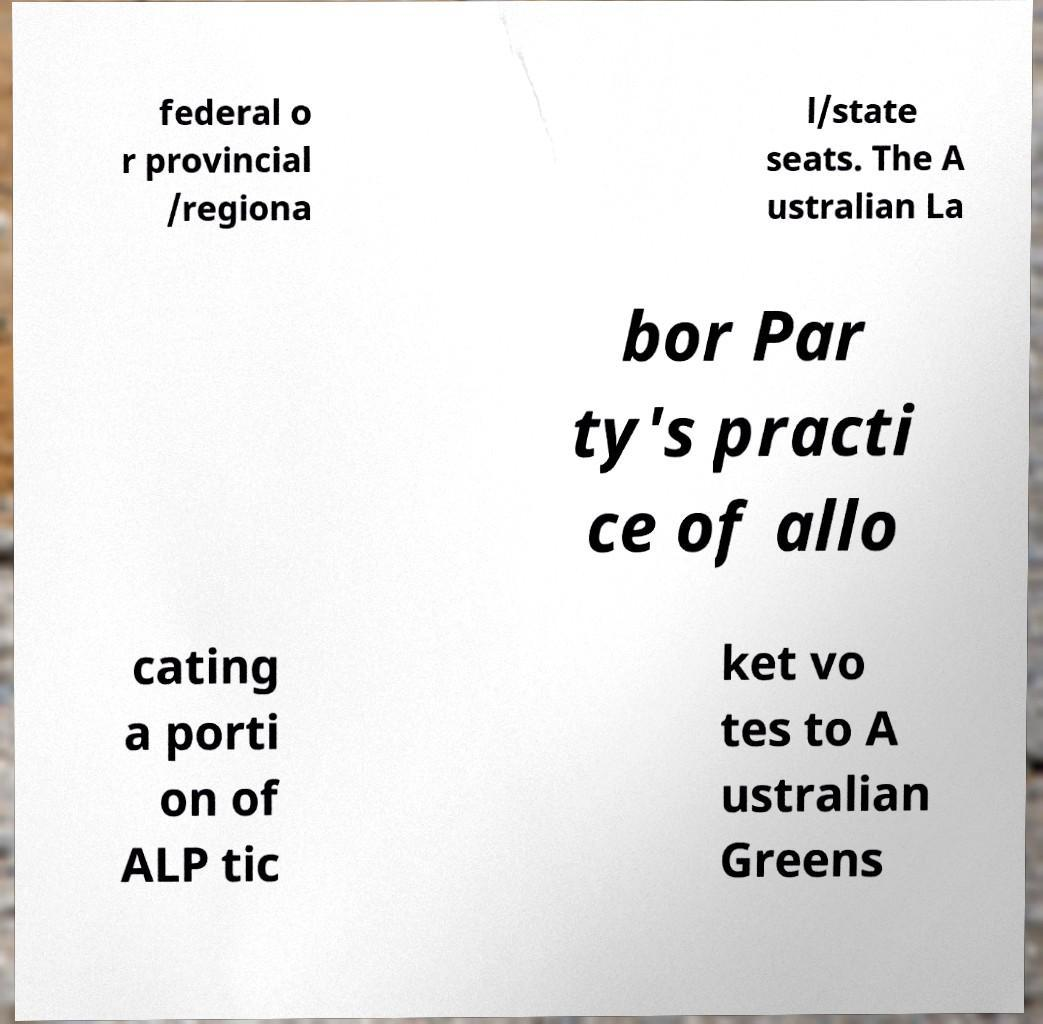Could you extract and type out the text from this image? federal o r provincial /regiona l/state seats. The A ustralian La bor Par ty's practi ce of allo cating a porti on of ALP tic ket vo tes to A ustralian Greens 